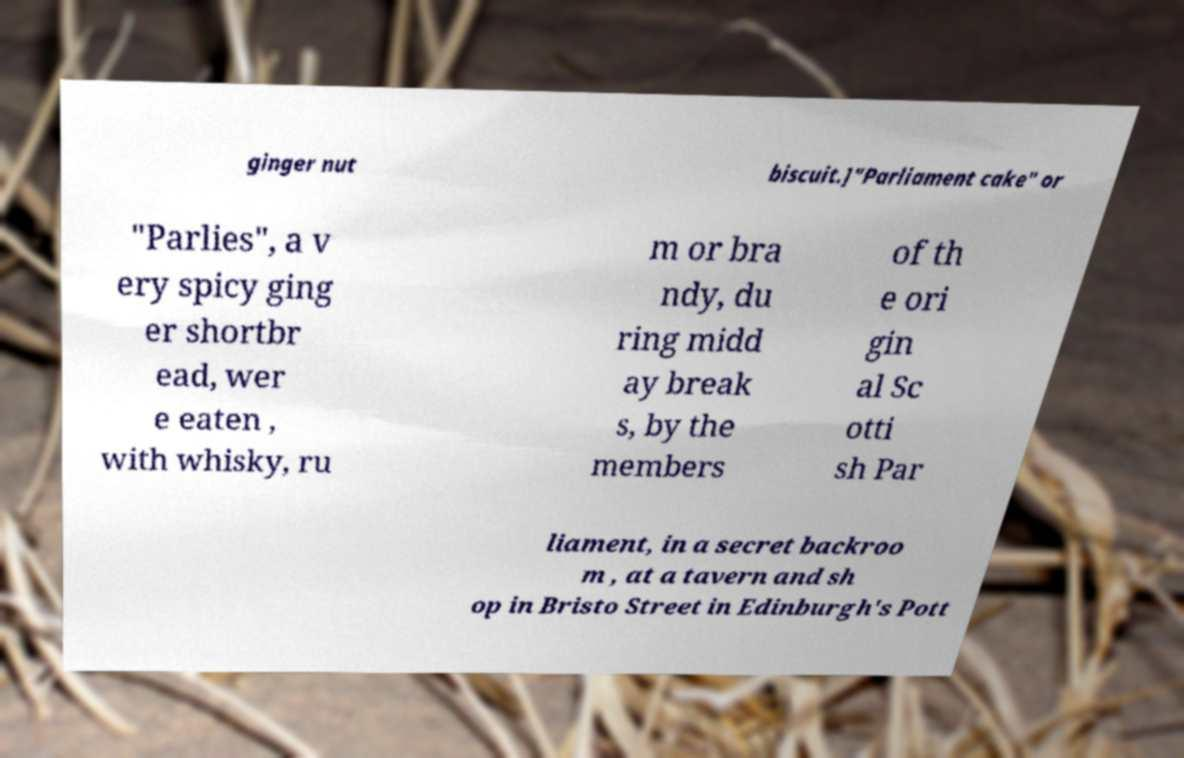Can you accurately transcribe the text from the provided image for me? ginger nut biscuit.]"Parliament cake" or "Parlies", a v ery spicy ging er shortbr ead, wer e eaten , with whisky, ru m or bra ndy, du ring midd ay break s, by the members of th e ori gin al Sc otti sh Par liament, in a secret backroo m , at a tavern and sh op in Bristo Street in Edinburgh's Pott 